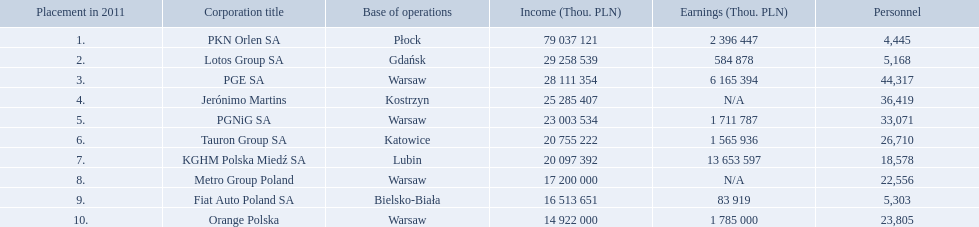What company has 28 111 354 thou.in revenue? PGE SA. What revenue does lotus group sa have? 29 258 539. Who has the next highest revenue than lotus group sa? PKN Orlen SA. Which concern's headquarters are located in warsaw? PGE SA, PGNiG SA, Metro Group Poland. Which of these listed a profit? PGE SA, PGNiG SA. Of these how many employees are in the concern with the lowest profit? 33,071. 